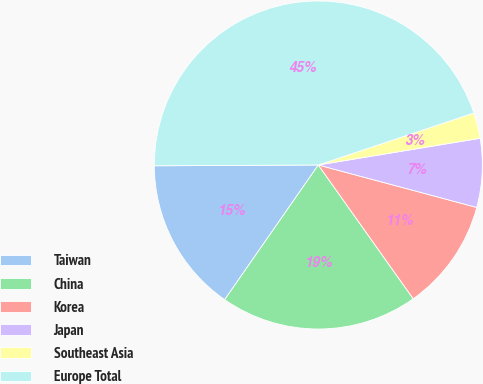<chart> <loc_0><loc_0><loc_500><loc_500><pie_chart><fcel>Taiwan<fcel>China<fcel>Korea<fcel>Japan<fcel>Southeast Asia<fcel>Europe Total<nl><fcel>15.25%<fcel>19.49%<fcel>11.01%<fcel>6.77%<fcel>2.53%<fcel>44.94%<nl></chart> 